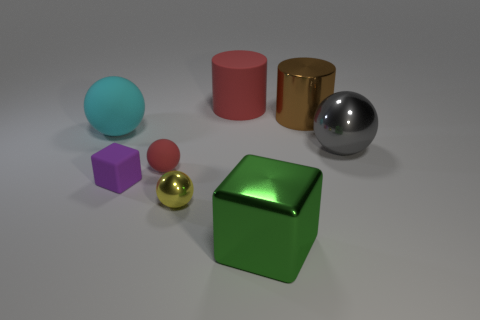Subtract all tiny yellow metal spheres. How many spheres are left? 3 Add 2 large matte things. How many objects exist? 10 Subtract all green cubes. How many cubes are left? 1 Subtract all yellow balls. Subtract all blue blocks. How many balls are left? 3 Subtract all cylinders. How many objects are left? 6 Subtract all tiny yellow shiny cylinders. Subtract all brown shiny objects. How many objects are left? 7 Add 4 big metallic things. How many big metallic things are left? 7 Add 5 red matte things. How many red matte things exist? 7 Subtract 0 green balls. How many objects are left? 8 